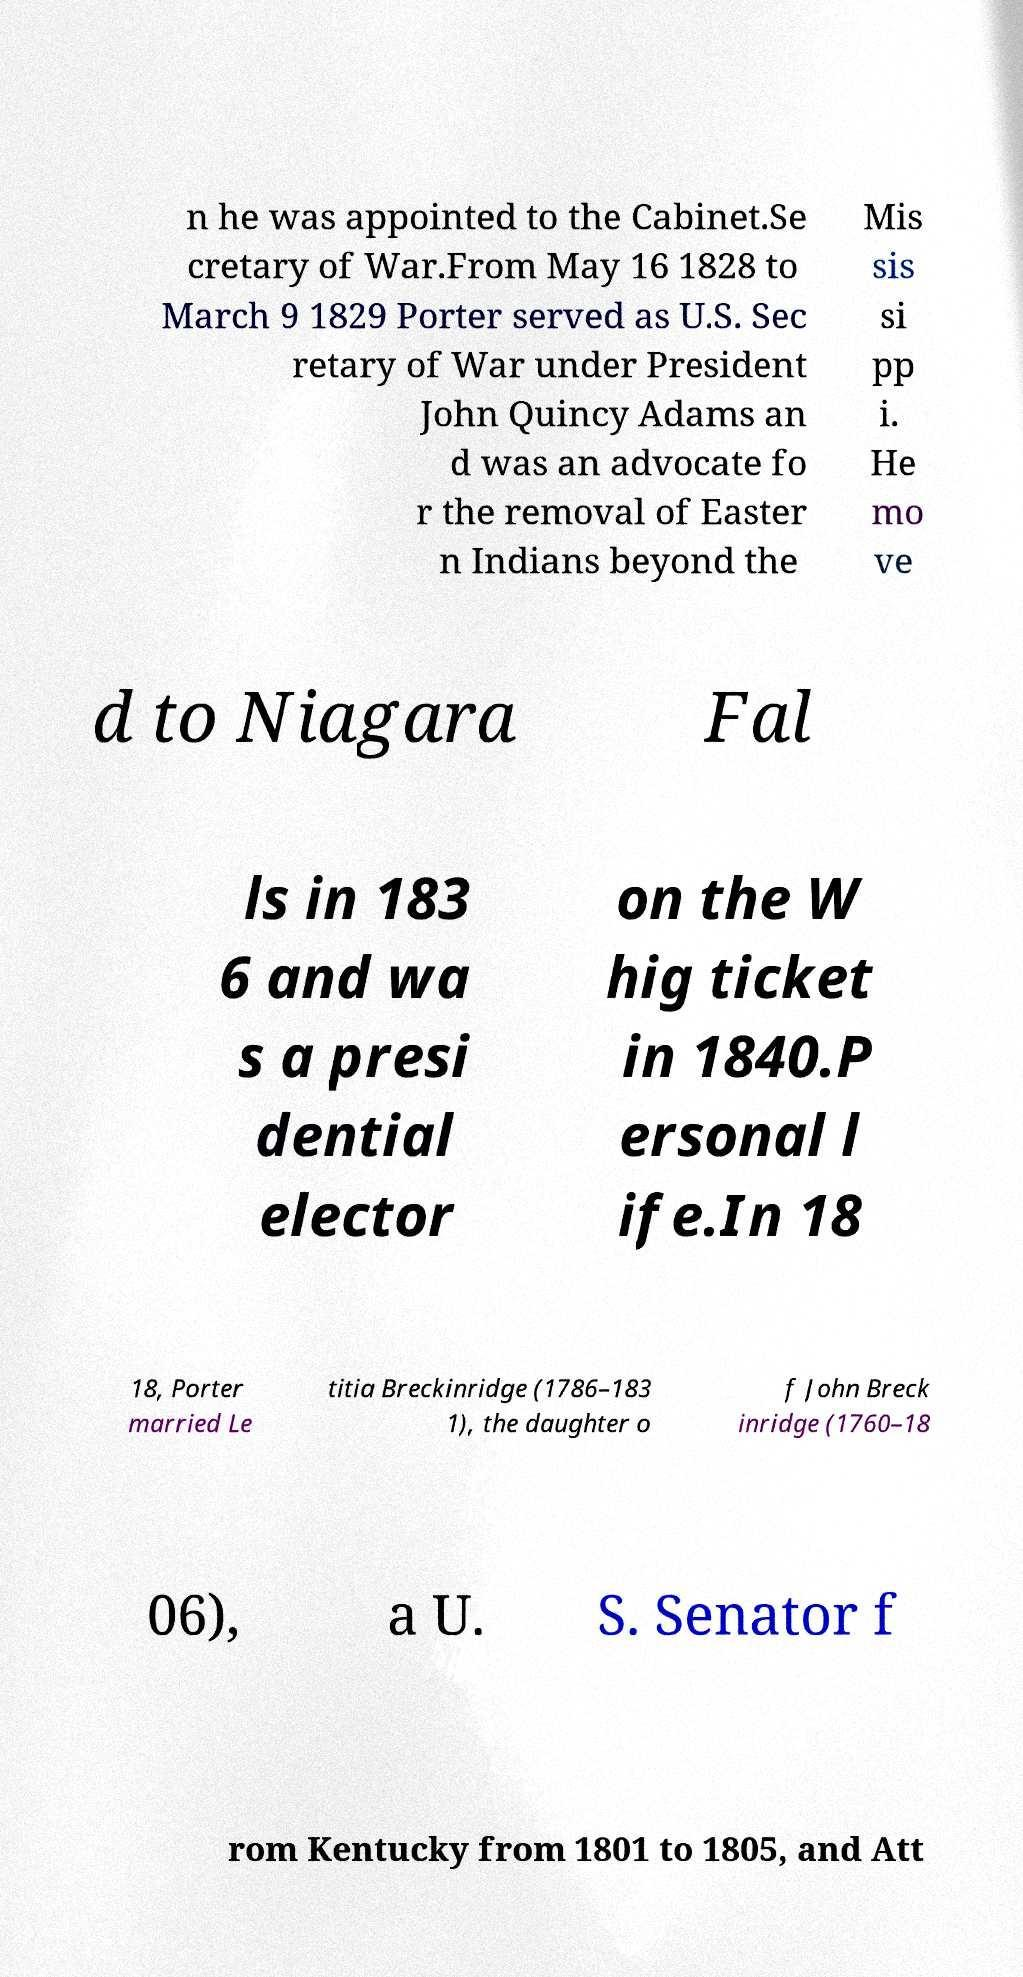Please identify and transcribe the text found in this image. n he was appointed to the Cabinet.Se cretary of War.From May 16 1828 to March 9 1829 Porter served as U.S. Sec retary of War under President John Quincy Adams an d was an advocate fo r the removal of Easter n Indians beyond the Mis sis si pp i. He mo ve d to Niagara Fal ls in 183 6 and wa s a presi dential elector on the W hig ticket in 1840.P ersonal l ife.In 18 18, Porter married Le titia Breckinridge (1786–183 1), the daughter o f John Breck inridge (1760–18 06), a U. S. Senator f rom Kentucky from 1801 to 1805, and Att 